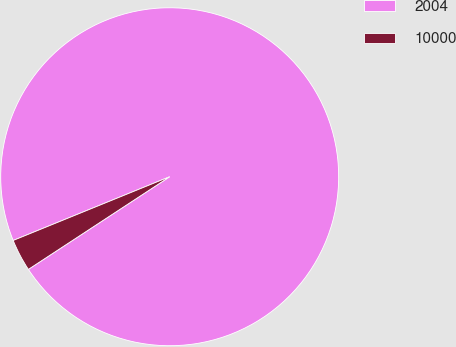Convert chart. <chart><loc_0><loc_0><loc_500><loc_500><pie_chart><fcel>2004<fcel>10000<nl><fcel>96.92%<fcel>3.08%<nl></chart> 